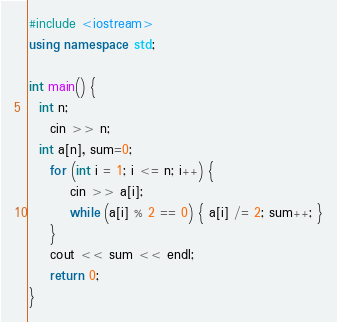Convert code to text. <code><loc_0><loc_0><loc_500><loc_500><_C++_>#include <iostream>
using namespace std;

int main() {
  int n;
	cin >> n;
  int a[n], sum=0;
	for (int i = 1; i <= n; i++) {
		cin >> a[i];
		while (a[i] % 2 == 0) { a[i] /= 2; sum++; }
	}
	cout << sum << endl;
	return 0;
}</code> 